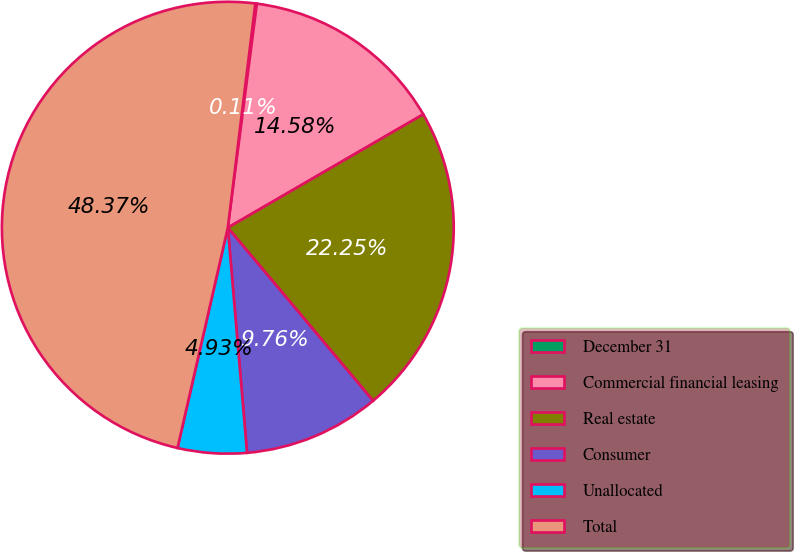Convert chart to OTSL. <chart><loc_0><loc_0><loc_500><loc_500><pie_chart><fcel>December 31<fcel>Commercial financial leasing<fcel>Real estate<fcel>Consumer<fcel>Unallocated<fcel>Total<nl><fcel>0.11%<fcel>14.58%<fcel>22.25%<fcel>9.76%<fcel>4.93%<fcel>48.37%<nl></chart> 